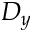Convert formula to latex. <formula><loc_0><loc_0><loc_500><loc_500>D _ { y }</formula> 